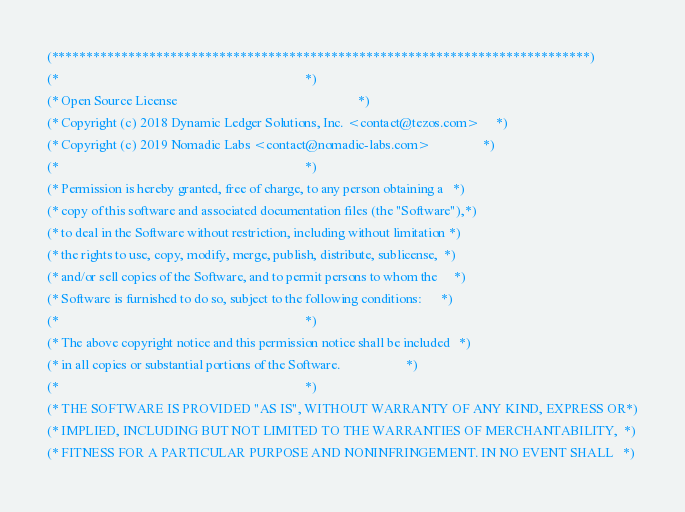<code> <loc_0><loc_0><loc_500><loc_500><_OCaml_>(*****************************************************************************)
(*                                                                           *)
(* Open Source License                                                       *)
(* Copyright (c) 2018 Dynamic Ledger Solutions, Inc. <contact@tezos.com>     *)
(* Copyright (c) 2019 Nomadic Labs <contact@nomadic-labs.com>                *)
(*                                                                           *)
(* Permission is hereby granted, free of charge, to any person obtaining a   *)
(* copy of this software and associated documentation files (the "Software"),*)
(* to deal in the Software without restriction, including without limitation *)
(* the rights to use, copy, modify, merge, publish, distribute, sublicense,  *)
(* and/or sell copies of the Software, and to permit persons to whom the     *)
(* Software is furnished to do so, subject to the following conditions:      *)
(*                                                                           *)
(* The above copyright notice and this permission notice shall be included   *)
(* in all copies or substantial portions of the Software.                    *)
(*                                                                           *)
(* THE SOFTWARE IS PROVIDED "AS IS", WITHOUT WARRANTY OF ANY KIND, EXPRESS OR*)
(* IMPLIED, INCLUDING BUT NOT LIMITED TO THE WARRANTIES OF MERCHANTABILITY,  *)
(* FITNESS FOR A PARTICULAR PURPOSE AND NONINFRINGEMENT. IN NO EVENT SHALL   *)</code> 